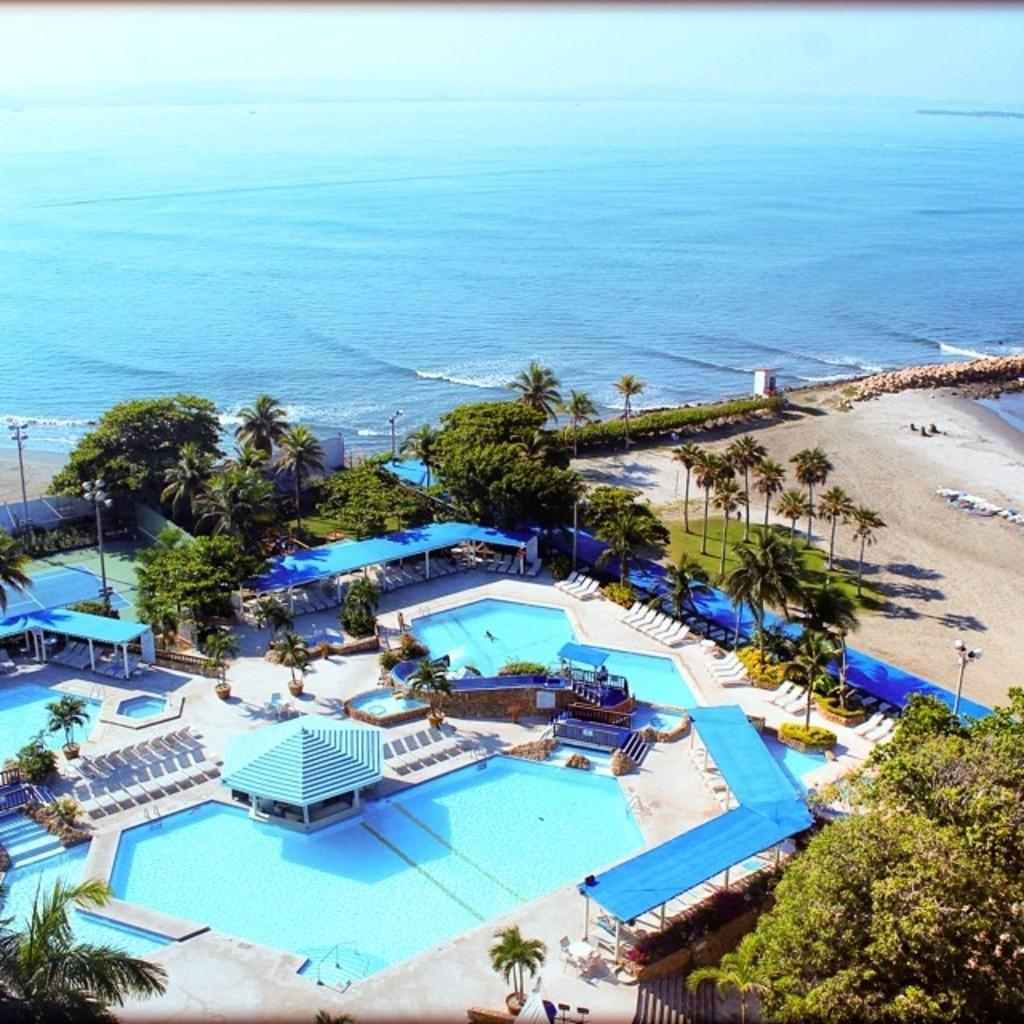What type of view is shown in the image? The image is an aerial view. What can be seen in the image that is typically used for recreational activities? There is a swimming pool in the image. What type of vegetation is visible in the image? There are trees visible in the image. What structure is located at the center of the image? There is a shed at the center of the image. What large body of water is visible in the image? There is a sea in the image. What is the primary substance visible in the image? Water is visible in the image. What type of garden can be seen in the image? There is no garden present in the image. What type of liquid is visible in the image? The primary substance visible in the image is water, which is not a liquid in the context of this question. Water is a liquid in general, but in this specific context, it is not a liquid but rather a substance that makes up the sea and swimming pool. 